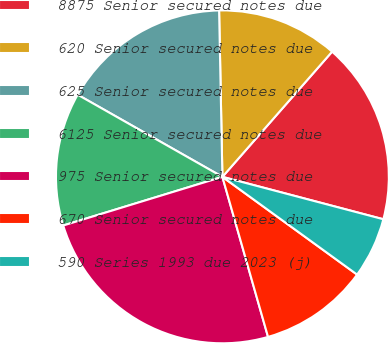Convert chart to OTSL. <chart><loc_0><loc_0><loc_500><loc_500><pie_chart><fcel>8875 Senior secured notes due<fcel>620 Senior secured notes due<fcel>625 Senior secured notes due<fcel>6125 Senior secured notes due<fcel>975 Senior secured notes due<fcel>670 Senior secured notes due<fcel>590 Series 1993 due 2023 (j)<nl><fcel>17.65%<fcel>11.77%<fcel>16.47%<fcel>12.94%<fcel>24.7%<fcel>10.59%<fcel>5.89%<nl></chart> 